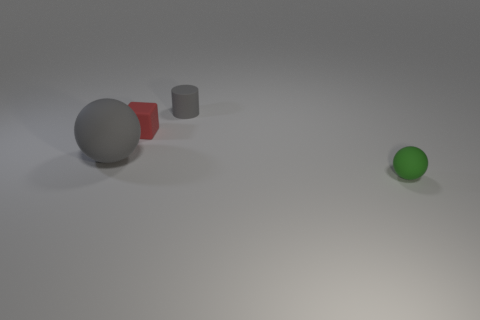Add 1 tiny gray matte objects. How many objects exist? 5 Subtract all cylinders. How many objects are left? 3 Subtract all small cylinders. Subtract all tiny red cubes. How many objects are left? 2 Add 2 gray rubber cylinders. How many gray rubber cylinders are left? 3 Add 4 large things. How many large things exist? 5 Subtract 1 red cubes. How many objects are left? 3 